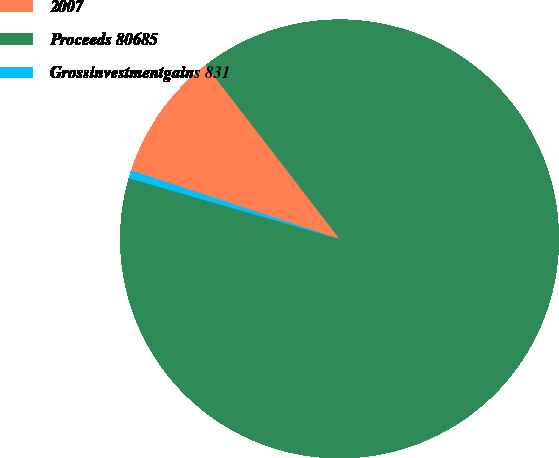<chart> <loc_0><loc_0><loc_500><loc_500><pie_chart><fcel>2007<fcel>Proceeds 80685<fcel>Grossinvestmentgains 831<nl><fcel>9.51%<fcel>89.91%<fcel>0.58%<nl></chart> 